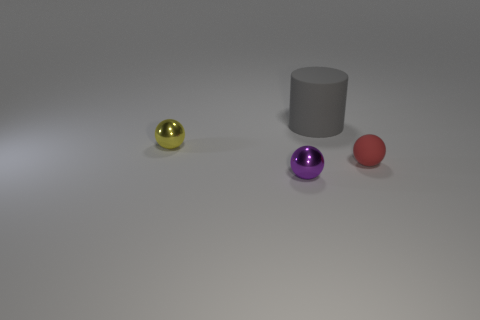There is a ball that is in front of the red thing; is its size the same as the object that is behind the tiny yellow metallic sphere? No, the ball in front of the red object is not the same size as the object behind the tiny yellow metallic sphere. The ball in front appears to be larger than the cylindrical object in the back when observing their relative sizes in the image. 